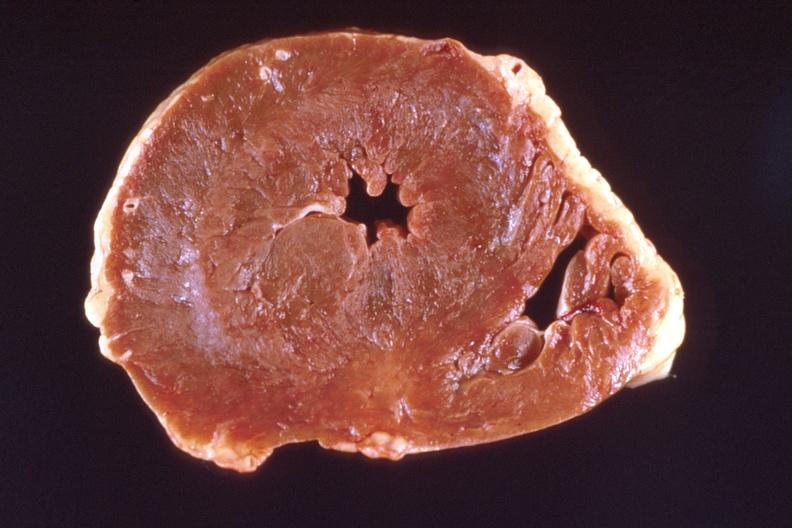what is present?
Answer the question using a single word or phrase. Cardiovascular 